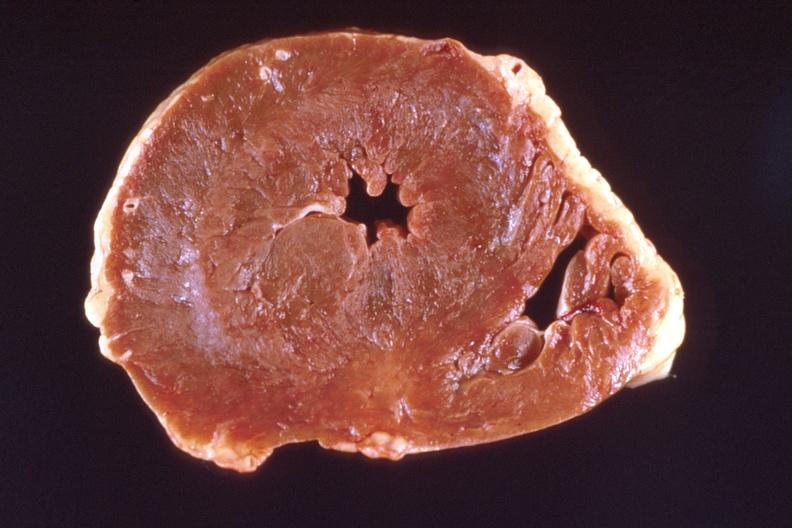what is present?
Answer the question using a single word or phrase. Cardiovascular 